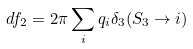<formula> <loc_0><loc_0><loc_500><loc_500>d f _ { 2 } = 2 \pi \sum _ { i } q _ { i } \delta _ { 3 } ( S _ { 3 } \rightarrow i )</formula> 